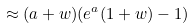Convert formula to latex. <formula><loc_0><loc_0><loc_500><loc_500>\approx ( a + w ) ( e ^ { a } ( 1 + w ) - 1 )</formula> 